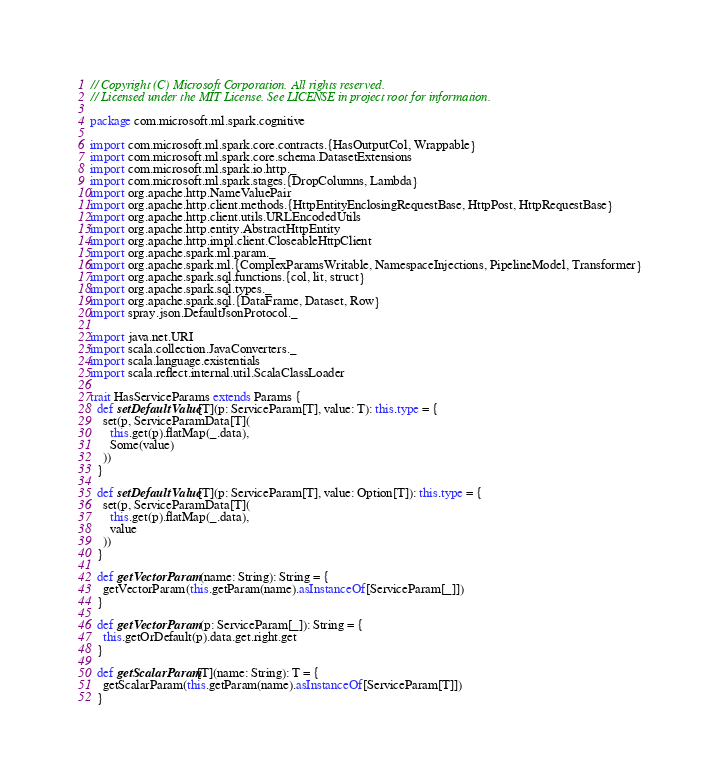<code> <loc_0><loc_0><loc_500><loc_500><_Scala_>// Copyright (C) Microsoft Corporation. All rights reserved.
// Licensed under the MIT License. See LICENSE in project root for information.

package com.microsoft.ml.spark.cognitive

import com.microsoft.ml.spark.core.contracts.{HasOutputCol, Wrappable}
import com.microsoft.ml.spark.core.schema.DatasetExtensions
import com.microsoft.ml.spark.io.http._
import com.microsoft.ml.spark.stages.{DropColumns, Lambda}
import org.apache.http.NameValuePair
import org.apache.http.client.methods.{HttpEntityEnclosingRequestBase, HttpPost, HttpRequestBase}
import org.apache.http.client.utils.URLEncodedUtils
import org.apache.http.entity.AbstractHttpEntity
import org.apache.http.impl.client.CloseableHttpClient
import org.apache.spark.ml.param._
import org.apache.spark.ml.{ComplexParamsWritable, NamespaceInjections, PipelineModel, Transformer}
import org.apache.spark.sql.functions.{col, lit, struct}
import org.apache.spark.sql.types._
import org.apache.spark.sql.{DataFrame, Dataset, Row}
import spray.json.DefaultJsonProtocol._

import java.net.URI
import scala.collection.JavaConverters._
import scala.language.existentials
import scala.reflect.internal.util.ScalaClassLoader

trait HasServiceParams extends Params {
  def setDefaultValue[T](p: ServiceParam[T], value: T): this.type = {
    set(p, ServiceParamData[T](
      this.get(p).flatMap(_.data),
      Some(value)
    ))
  }

  def setDefaultValue[T](p: ServiceParam[T], value: Option[T]): this.type = {
    set(p, ServiceParamData[T](
      this.get(p).flatMap(_.data),
      value
    ))
  }

  def getVectorParam(name: String): String = {
    getVectorParam(this.getParam(name).asInstanceOf[ServiceParam[_]])
  }

  def getVectorParam(p: ServiceParam[_]): String = {
    this.getOrDefault(p).data.get.right.get
  }

  def getScalarParam[T](name: String): T = {
    getScalarParam(this.getParam(name).asInstanceOf[ServiceParam[T]])
  }
</code> 